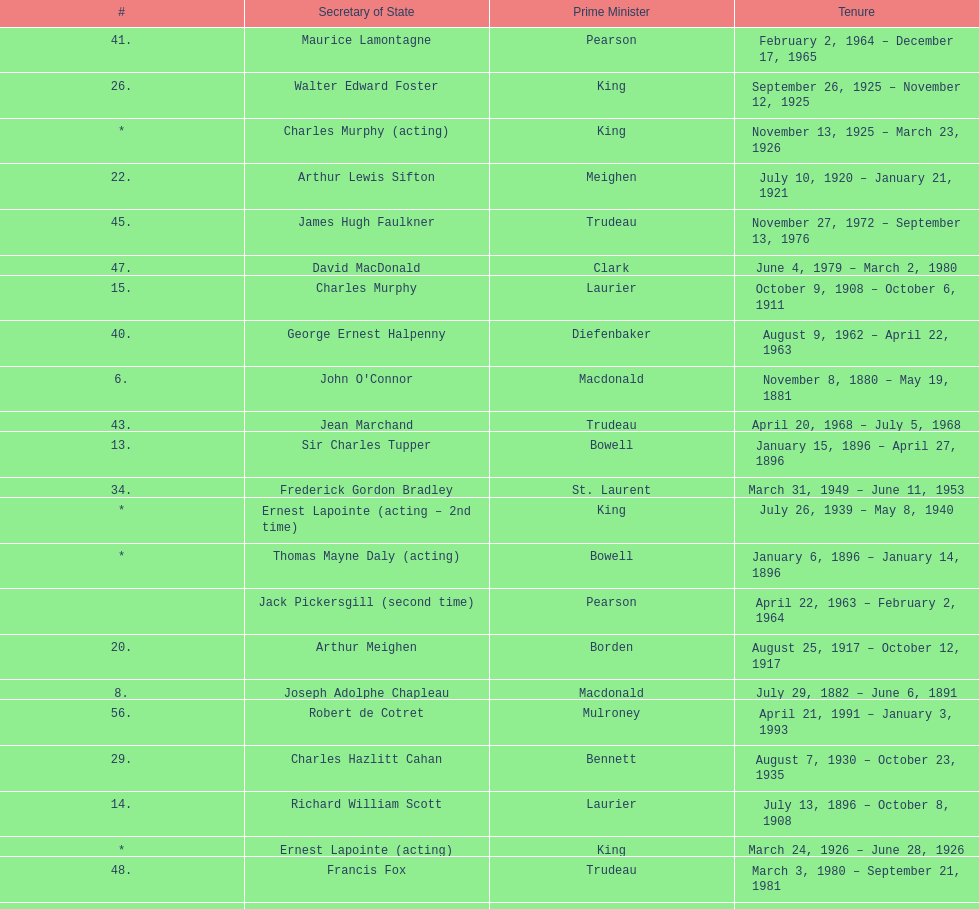Which secretary of state came after jack pkckersgill? Roch Pinard. 